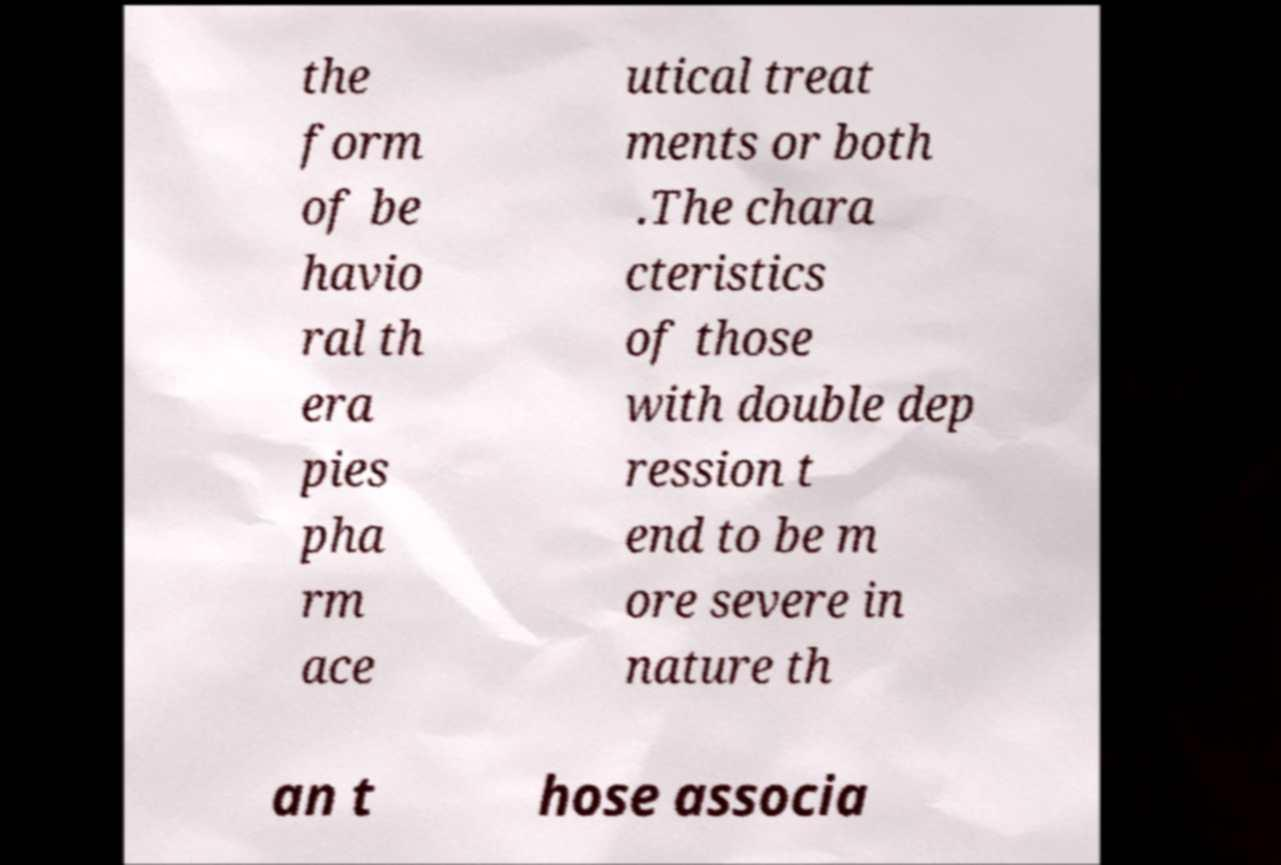What messages or text are displayed in this image? I need them in a readable, typed format. the form of be havio ral th era pies pha rm ace utical treat ments or both .The chara cteristics of those with double dep ression t end to be m ore severe in nature th an t hose associa 